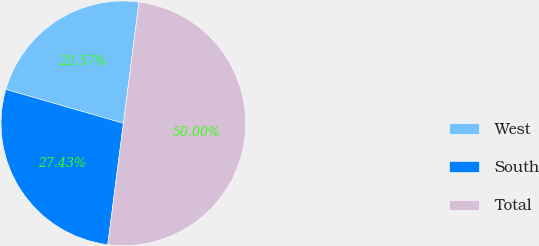<chart> <loc_0><loc_0><loc_500><loc_500><pie_chart><fcel>West<fcel>South<fcel>Total<nl><fcel>22.57%<fcel>27.43%<fcel>50.0%<nl></chart> 